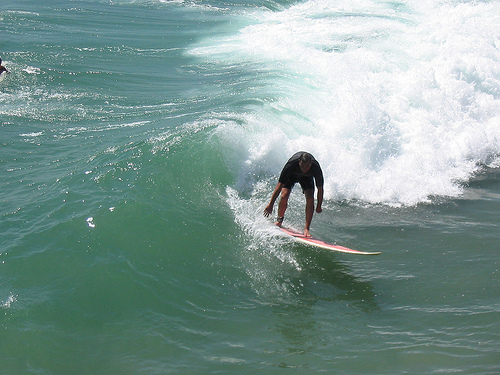Please provide a short description for this region: [0.44, 0.19, 0.61, 0.31]. This area depicts small ripples in the water, possibly influenced by the nearby surfer's movements and the dynamic ocean conditions. 